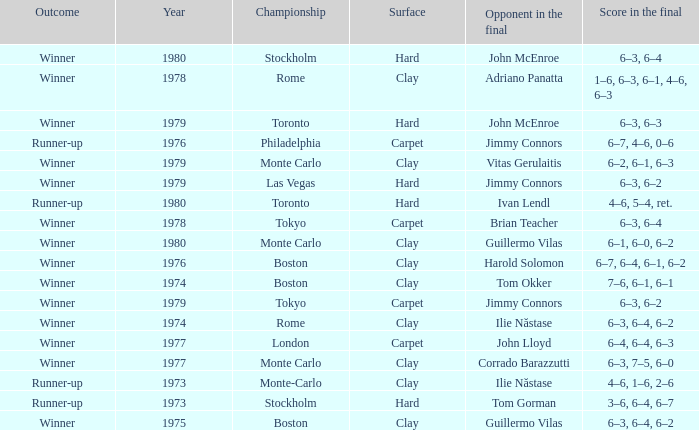Name the total number of opponent in the final for 6–2, 6–1, 6–3 1.0. 